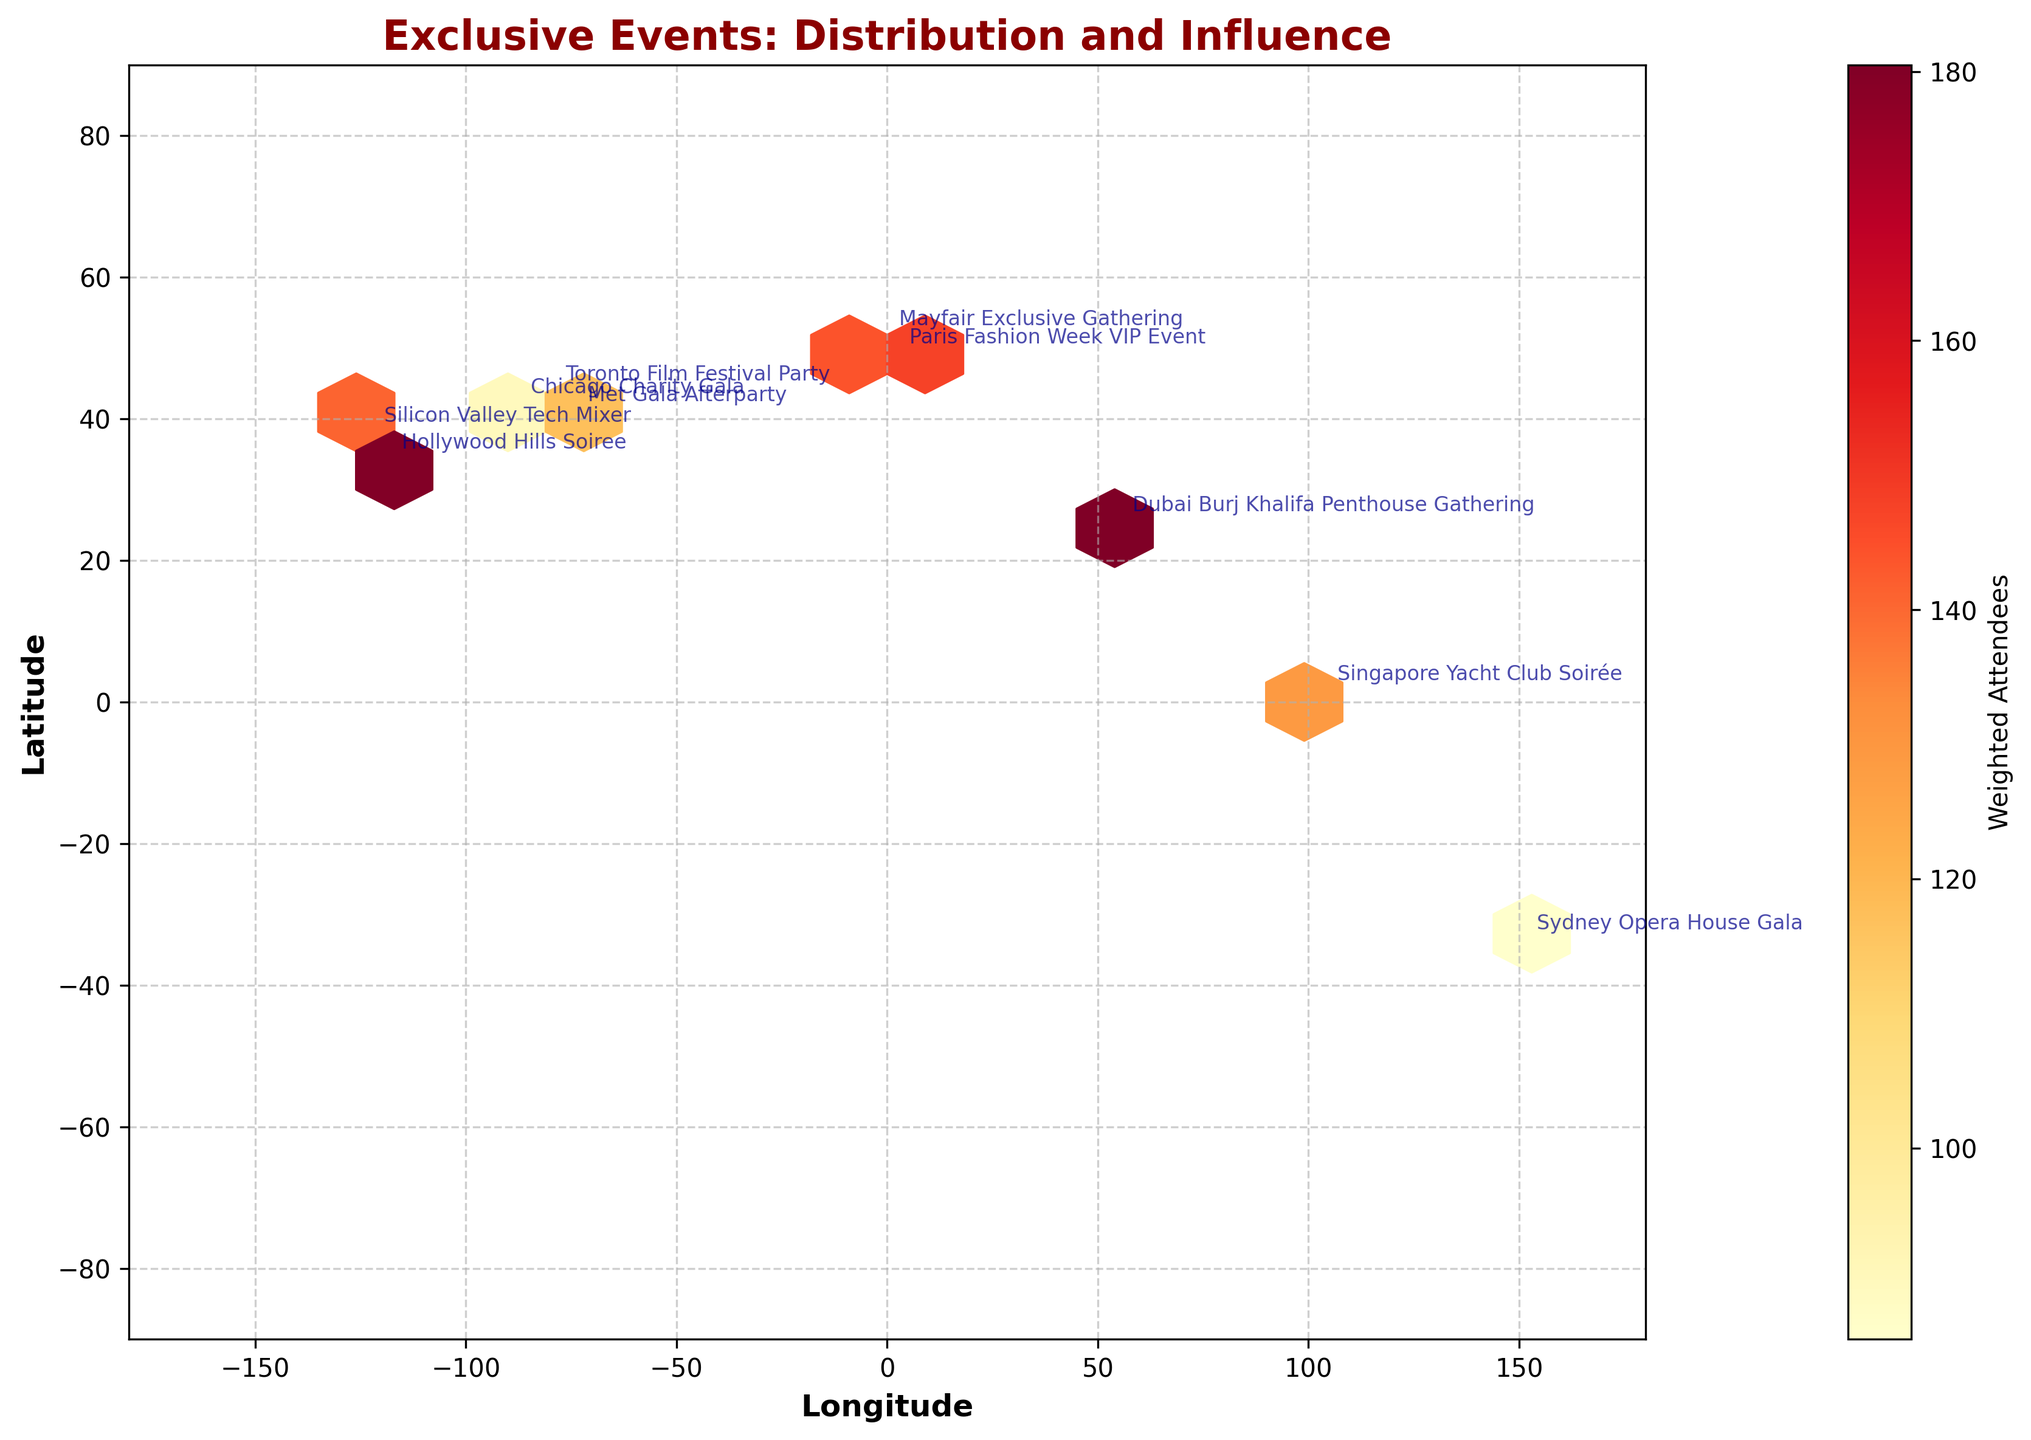What is the title of the hexbin plot? Look at the top center of the figure, where the title is typically displayed. The title summarizes the main theme of the plot.
Answer: Exclusive Events: Distribution and Influence How many high-attendee events are placed in the hexbin plot? Identify the number of points with attendee counts noticeably higher than others, which are also annotated with their event names.
Answer: 2 Which event takes place closest to the equator? Look at the latitude on the y-axis and find the event with coordinates closest to 0.
Answer: Singapore Yacht Club Soirée Which event has the highest weighted number of attendees? The color intensity of the hexbin cells indicates the weighted number of attendees; the darker the cell, the higher the weighted number of attendees. Identifying the darkest hexbin cell will show the event.
Answer: Dubai Burj Khalifa Penthouse Gathering List the events in descending order by high-status percentage. Read the high-status percentages annotated with each hexbin and sort the events accordingly:
 - Dubai Burj Khalifa Penthouse Gathering (95%)
 - Singapore Yacht Club Soirée (92%)
 - Hollywood Hills Soiree (90%)
 - Silicon Valley Tech Mixer (88%)
 - Met Gala Afterparty (85%)
 - Paris Fashion Week VIP Event (87%)
 - Toronto Film Festival Party (82%)
 - Mayfair Exclusive Gathering (80%)
 - Sydney Opera House Gala (78%)
 - Chicago Charity Gala (75%)
Answer: Dubai Burj Khalifa Penthouse Gathering, Singapore Yacht Club Soirée, Hollywood Hills Soiree, Silicon Valley Tech Mixer, Paris Fashion Week VIP Event, Met Gala Afterparty, Toronto Film Festival Party, Mayfair Exclusive Gathering, Sydney Opera House Gala, Chicago Charity Gala Which continents have the highest number of events in this plot? Observe the longitude and latitude, aggregated points, and their corresponding continents based on their geographic locations.
Answer: North America, Europe, Asia Is there any region with no events plotted? Scan the entire plot to see if there are vast areas without any hexbin cells, indicating no events took place there.
Answer: Yes, there are no events plotted in Africa or Antarctica Compare the attendee counts for the Met Gala Afterparty and the Silicon Valley Tech Mixer. Which one had more attendees? Look at the annotations for these particular events on the plot and compare the respective attendee counts.
Answer: Silicon Valley Tech Mixer Which event has the smallest number of attendees? Identify the event annotated with the lowest attendee count on the plot.
Answer: Sydney Opera House Gala What is the average latitude of all the plotted events? List out all the latitudes, sum them up, and then divide by the number of events. (40.7128 + 34.0522 + 51.5074 + 41.8781 + 37.7749 + 1.3521 + 48.8566 + 43.6532 - 33.8688 + 25.2048) / 10
Answer: 29.2992 